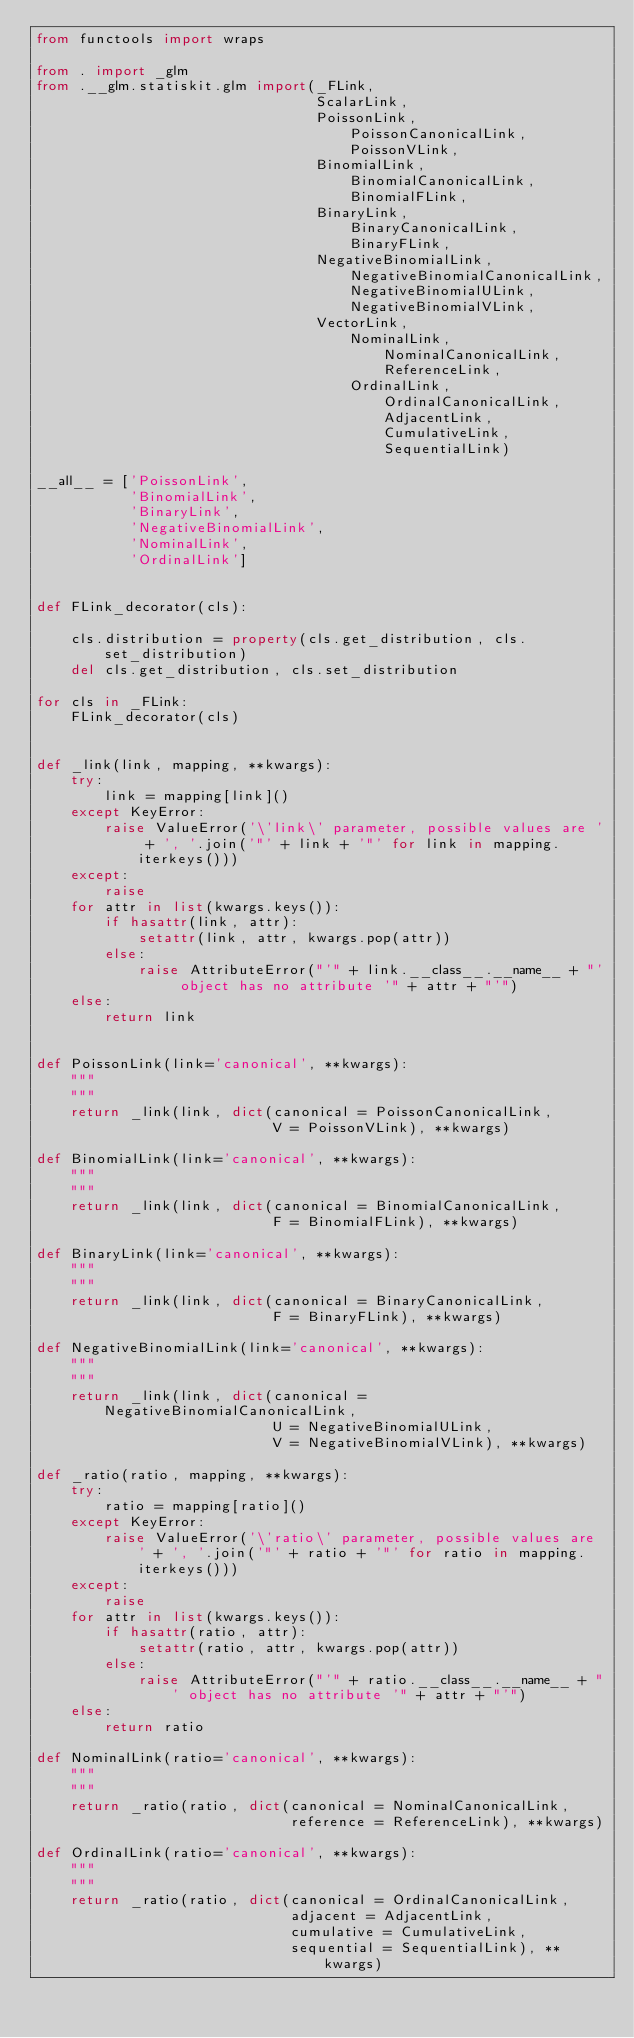Convert code to text. <code><loc_0><loc_0><loc_500><loc_500><_Python_>from functools import wraps

from . import _glm
from .__glm.statiskit.glm import(_FLink,
                                 ScalarLink,
                                 PoissonLink,
                                     PoissonCanonicalLink,
                                     PoissonVLink,
                                 BinomialLink,
                                     BinomialCanonicalLink,
                                     BinomialFLink,
                                 BinaryLink,
                                     BinaryCanonicalLink,
                                     BinaryFLink,
                                 NegativeBinomialLink,
                                     NegativeBinomialCanonicalLink,
                                     NegativeBinomialULink,
                                     NegativeBinomialVLink,
                                 VectorLink,
                                     NominalLink,
                                         NominalCanonicalLink,
                                         ReferenceLink,
                                     OrdinalLink,
                                         OrdinalCanonicalLink,
                                         AdjacentLink,
                                         CumulativeLink,
                                         SequentialLink)

__all__ = ['PoissonLink',
           'BinomialLink',
           'BinaryLink',
           'NegativeBinomialLink',
           'NominalLink',
           'OrdinalLink']


def FLink_decorator(cls):

    cls.distribution = property(cls.get_distribution, cls.set_distribution)
    del cls.get_distribution, cls.set_distribution

for cls in _FLink:
    FLink_decorator(cls)


def _link(link, mapping, **kwargs):
    try:
        link = mapping[link]()
    except KeyError:
        raise ValueError('\'link\' parameter, possible values are ' + ', '.join('"' + link + '"' for link in mapping.iterkeys()))
    except:
        raise
    for attr in list(kwargs.keys()):
        if hasattr(link, attr):
            setattr(link, attr, kwargs.pop(attr))
        else:
            raise AttributeError("'" + link.__class__.__name__ + "' object has no attribute '" + attr + "'")
    else:
        return link


def PoissonLink(link='canonical', **kwargs): 
    """
    """
    return _link(link, dict(canonical = PoissonCanonicalLink,
                            V = PoissonVLink), **kwargs)

def BinomialLink(link='canonical', **kwargs): 
    """
    """
    return _link(link, dict(canonical = BinomialCanonicalLink,
                            F = BinomialFLink), **kwargs)

def BinaryLink(link='canonical', **kwargs): 
    """
    """
    return _link(link, dict(canonical = BinaryCanonicalLink,
                            F = BinaryFLink), **kwargs)

def NegativeBinomialLink(link='canonical', **kwargs): 
    """
    """
    return _link(link, dict(canonical = NegativeBinomialCanonicalLink,
                            U = NegativeBinomialULink,
                            V = NegativeBinomialVLink), **kwargs)

def _ratio(ratio, mapping, **kwargs):
    try:
        ratio = mapping[ratio]()
    except KeyError:
        raise ValueError('\'ratio\' parameter, possible values are ' + ', '.join('"' + ratio + '"' for ratio in mapping.iterkeys()))
    except:
        raise
    for attr in list(kwargs.keys()):
        if hasattr(ratio, attr):
            setattr(ratio, attr, kwargs.pop(attr))
        else:
            raise AttributeError("'" + ratio.__class__.__name__ + "' object has no attribute '" + attr + "'")
    else:
        return ratio

def NominalLink(ratio='canonical', **kwargs):
    """
    """
    return _ratio(ratio, dict(canonical = NominalCanonicalLink,
                              reference = ReferenceLink), **kwargs)

def OrdinalLink(ratio='canonical', **kwargs):
    """
    """
    return _ratio(ratio, dict(canonical = OrdinalCanonicalLink,
                              adjacent = AdjacentLink,
                              cumulative = CumulativeLink,
                              sequential = SequentialLink), **kwargs)</code> 